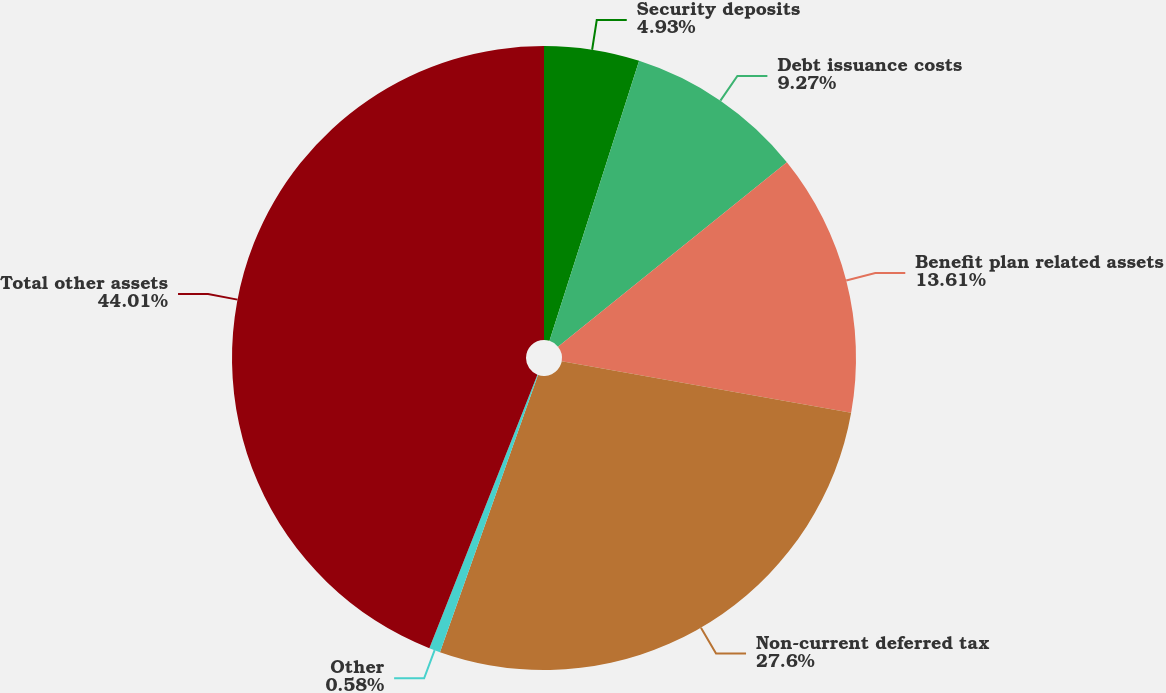Convert chart. <chart><loc_0><loc_0><loc_500><loc_500><pie_chart><fcel>Security deposits<fcel>Debt issuance costs<fcel>Benefit plan related assets<fcel>Non-current deferred tax<fcel>Other<fcel>Total other assets<nl><fcel>4.93%<fcel>9.27%<fcel>13.61%<fcel>27.6%<fcel>0.58%<fcel>44.01%<nl></chart> 